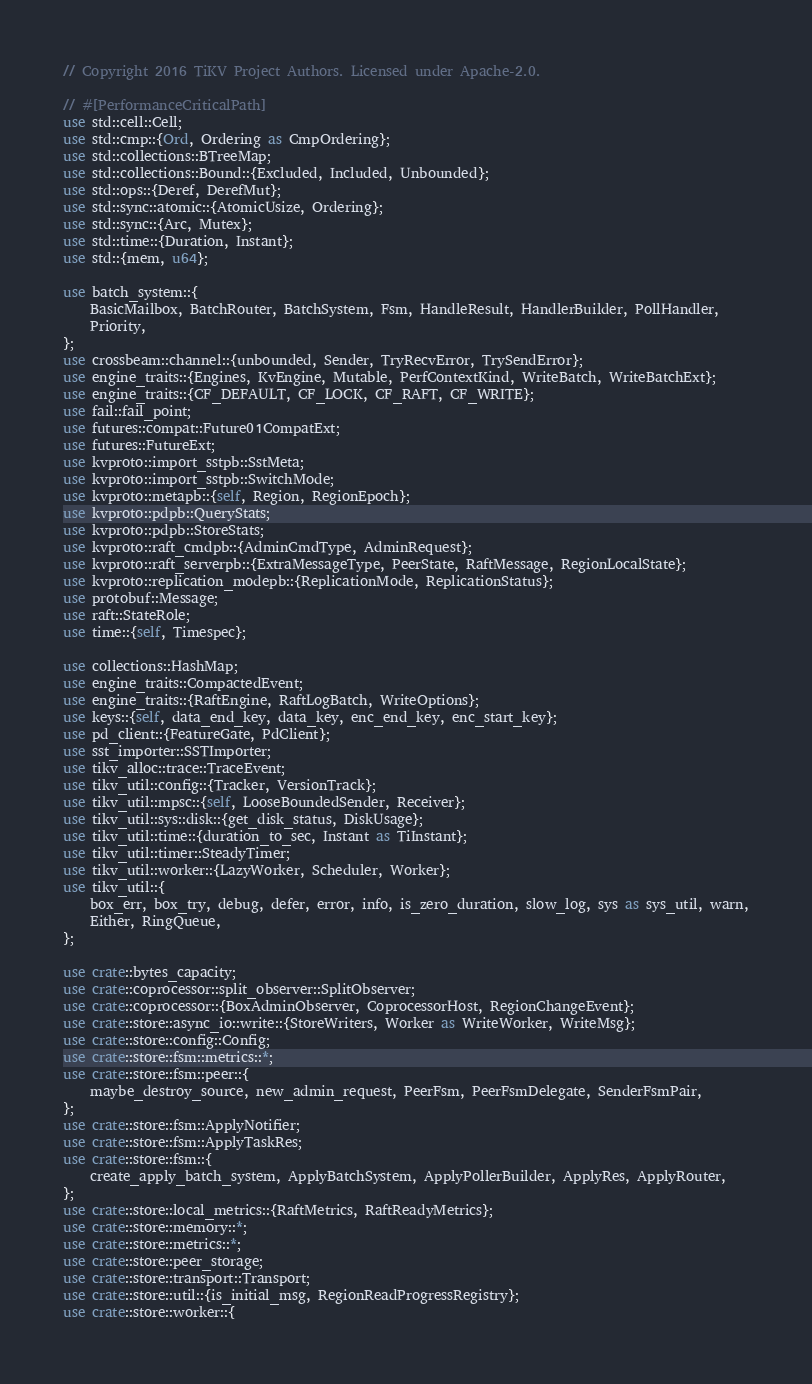<code> <loc_0><loc_0><loc_500><loc_500><_Rust_>// Copyright 2016 TiKV Project Authors. Licensed under Apache-2.0.

// #[PerformanceCriticalPath]
use std::cell::Cell;
use std::cmp::{Ord, Ordering as CmpOrdering};
use std::collections::BTreeMap;
use std::collections::Bound::{Excluded, Included, Unbounded};
use std::ops::{Deref, DerefMut};
use std::sync::atomic::{AtomicUsize, Ordering};
use std::sync::{Arc, Mutex};
use std::time::{Duration, Instant};
use std::{mem, u64};

use batch_system::{
    BasicMailbox, BatchRouter, BatchSystem, Fsm, HandleResult, HandlerBuilder, PollHandler,
    Priority,
};
use crossbeam::channel::{unbounded, Sender, TryRecvError, TrySendError};
use engine_traits::{Engines, KvEngine, Mutable, PerfContextKind, WriteBatch, WriteBatchExt};
use engine_traits::{CF_DEFAULT, CF_LOCK, CF_RAFT, CF_WRITE};
use fail::fail_point;
use futures::compat::Future01CompatExt;
use futures::FutureExt;
use kvproto::import_sstpb::SstMeta;
use kvproto::import_sstpb::SwitchMode;
use kvproto::metapb::{self, Region, RegionEpoch};
use kvproto::pdpb::QueryStats;
use kvproto::pdpb::StoreStats;
use kvproto::raft_cmdpb::{AdminCmdType, AdminRequest};
use kvproto::raft_serverpb::{ExtraMessageType, PeerState, RaftMessage, RegionLocalState};
use kvproto::replication_modepb::{ReplicationMode, ReplicationStatus};
use protobuf::Message;
use raft::StateRole;
use time::{self, Timespec};

use collections::HashMap;
use engine_traits::CompactedEvent;
use engine_traits::{RaftEngine, RaftLogBatch, WriteOptions};
use keys::{self, data_end_key, data_key, enc_end_key, enc_start_key};
use pd_client::{FeatureGate, PdClient};
use sst_importer::SSTImporter;
use tikv_alloc::trace::TraceEvent;
use tikv_util::config::{Tracker, VersionTrack};
use tikv_util::mpsc::{self, LooseBoundedSender, Receiver};
use tikv_util::sys::disk::{get_disk_status, DiskUsage};
use tikv_util::time::{duration_to_sec, Instant as TiInstant};
use tikv_util::timer::SteadyTimer;
use tikv_util::worker::{LazyWorker, Scheduler, Worker};
use tikv_util::{
    box_err, box_try, debug, defer, error, info, is_zero_duration, slow_log, sys as sys_util, warn,
    Either, RingQueue,
};

use crate::bytes_capacity;
use crate::coprocessor::split_observer::SplitObserver;
use crate::coprocessor::{BoxAdminObserver, CoprocessorHost, RegionChangeEvent};
use crate::store::async_io::write::{StoreWriters, Worker as WriteWorker, WriteMsg};
use crate::store::config::Config;
use crate::store::fsm::metrics::*;
use crate::store::fsm::peer::{
    maybe_destroy_source, new_admin_request, PeerFsm, PeerFsmDelegate, SenderFsmPair,
};
use crate::store::fsm::ApplyNotifier;
use crate::store::fsm::ApplyTaskRes;
use crate::store::fsm::{
    create_apply_batch_system, ApplyBatchSystem, ApplyPollerBuilder, ApplyRes, ApplyRouter,
};
use crate::store::local_metrics::{RaftMetrics, RaftReadyMetrics};
use crate::store::memory::*;
use crate::store::metrics::*;
use crate::store::peer_storage;
use crate::store::transport::Transport;
use crate::store::util::{is_initial_msg, RegionReadProgressRegistry};
use crate::store::worker::{</code> 